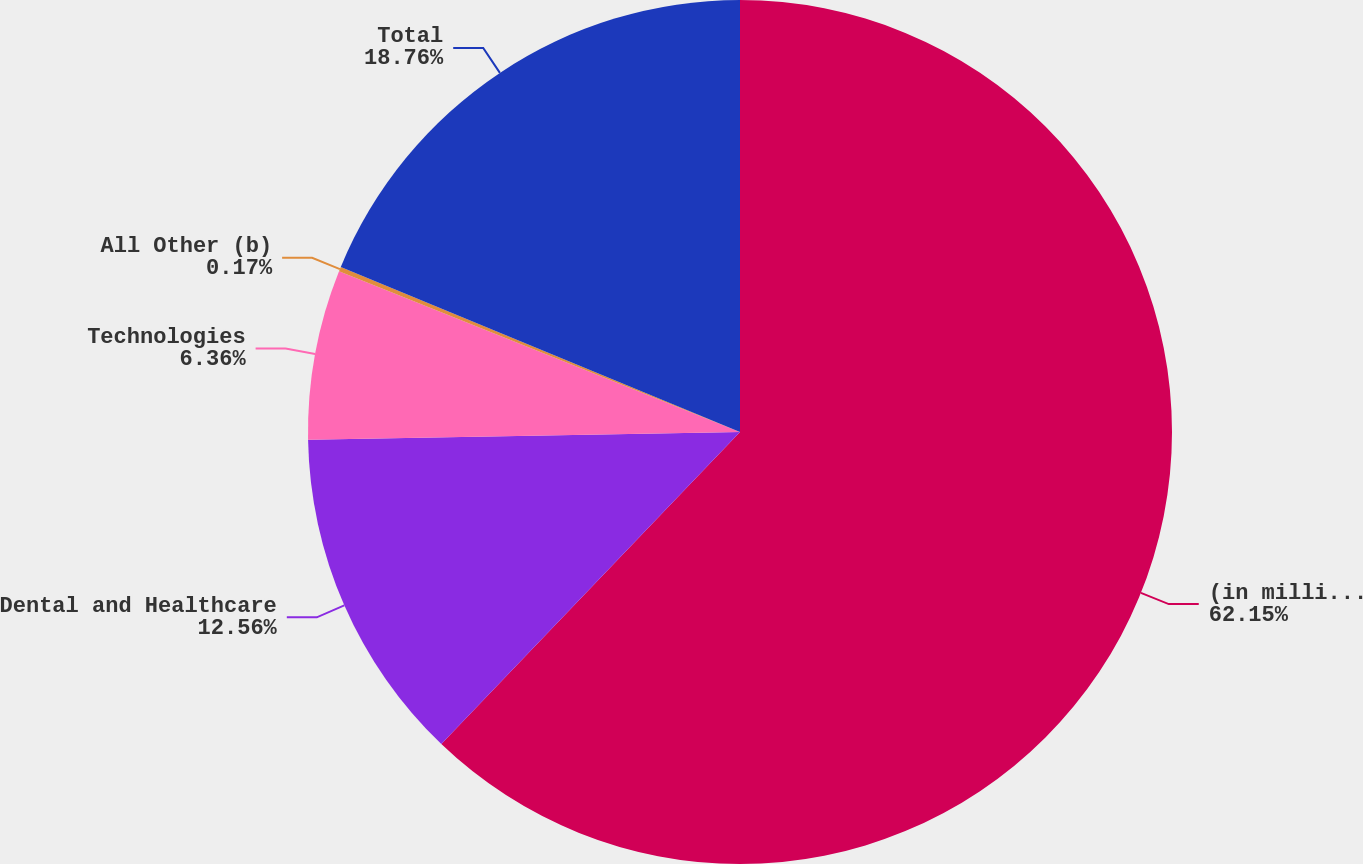Convert chart. <chart><loc_0><loc_0><loc_500><loc_500><pie_chart><fcel>(in millions)<fcel>Dental and Healthcare<fcel>Technologies<fcel>All Other (b)<fcel>Total<nl><fcel>62.15%<fcel>12.56%<fcel>6.36%<fcel>0.17%<fcel>18.76%<nl></chart> 